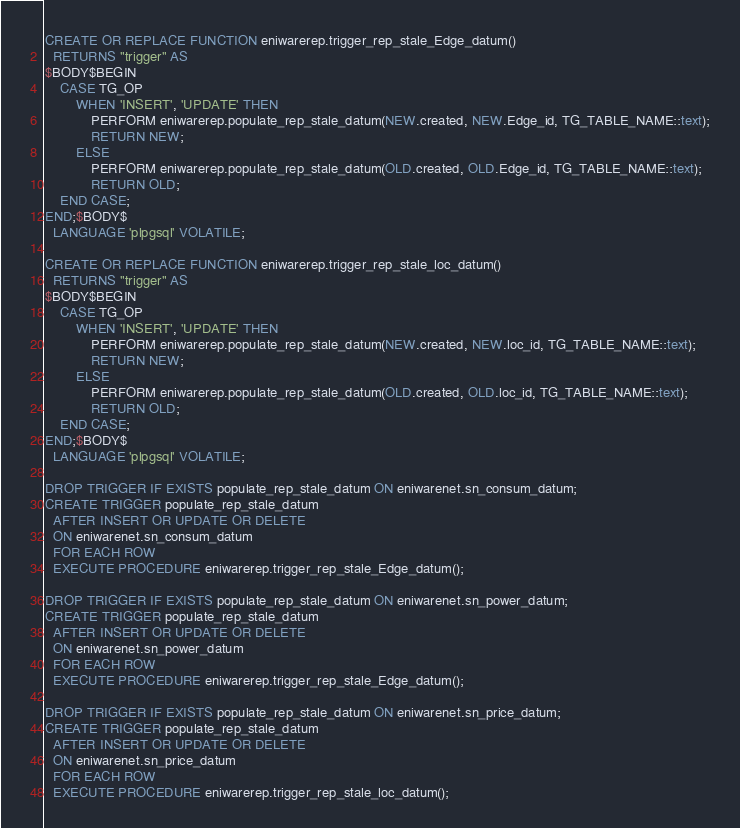<code> <loc_0><loc_0><loc_500><loc_500><_SQL_>CREATE OR REPLACE FUNCTION eniwarerep.trigger_rep_stale_Edge_datum()
  RETURNS "trigger" AS
$BODY$BEGIN
	CASE TG_OP
		WHEN 'INSERT', 'UPDATE' THEN
			PERFORM eniwarerep.populate_rep_stale_datum(NEW.created, NEW.Edge_id, TG_TABLE_NAME::text);
			RETURN NEW;
		ELSE
			PERFORM eniwarerep.populate_rep_stale_datum(OLD.created, OLD.Edge_id, TG_TABLE_NAME::text);
			RETURN OLD;
	END CASE;
END;$BODY$
  LANGUAGE 'plpgsql' VOLATILE;

CREATE OR REPLACE FUNCTION eniwarerep.trigger_rep_stale_loc_datum()
  RETURNS "trigger" AS
$BODY$BEGIN
	CASE TG_OP
		WHEN 'INSERT', 'UPDATE' THEN
			PERFORM eniwarerep.populate_rep_stale_datum(NEW.created, NEW.loc_id, TG_TABLE_NAME::text);
			RETURN NEW;
		ELSE
			PERFORM eniwarerep.populate_rep_stale_datum(OLD.created, OLD.loc_id, TG_TABLE_NAME::text);
			RETURN OLD;
	END CASE;
END;$BODY$
  LANGUAGE 'plpgsql' VOLATILE;

DROP TRIGGER IF EXISTS populate_rep_stale_datum ON eniwarenet.sn_consum_datum;
CREATE TRIGGER populate_rep_stale_datum
  AFTER INSERT OR UPDATE OR DELETE
  ON eniwarenet.sn_consum_datum
  FOR EACH ROW
  EXECUTE PROCEDURE eniwarerep.trigger_rep_stale_Edge_datum();

DROP TRIGGER IF EXISTS populate_rep_stale_datum ON eniwarenet.sn_power_datum;
CREATE TRIGGER populate_rep_stale_datum
  AFTER INSERT OR UPDATE OR DELETE
  ON eniwarenet.sn_power_datum
  FOR EACH ROW
  EXECUTE PROCEDURE eniwarerep.trigger_rep_stale_Edge_datum();

DROP TRIGGER IF EXISTS populate_rep_stale_datum ON eniwarenet.sn_price_datum;
CREATE TRIGGER populate_rep_stale_datum
  AFTER INSERT OR UPDATE OR DELETE
  ON eniwarenet.sn_price_datum
  FOR EACH ROW
  EXECUTE PROCEDURE eniwarerep.trigger_rep_stale_loc_datum();
</code> 